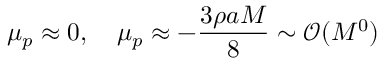Convert formula to latex. <formula><loc_0><loc_0><loc_500><loc_500>\mu _ { p } \approx 0 , \quad \mu _ { p } \approx - \frac { 3 \rho a M } { 8 } \sim \mathcal { O } ( M ^ { 0 } )</formula> 